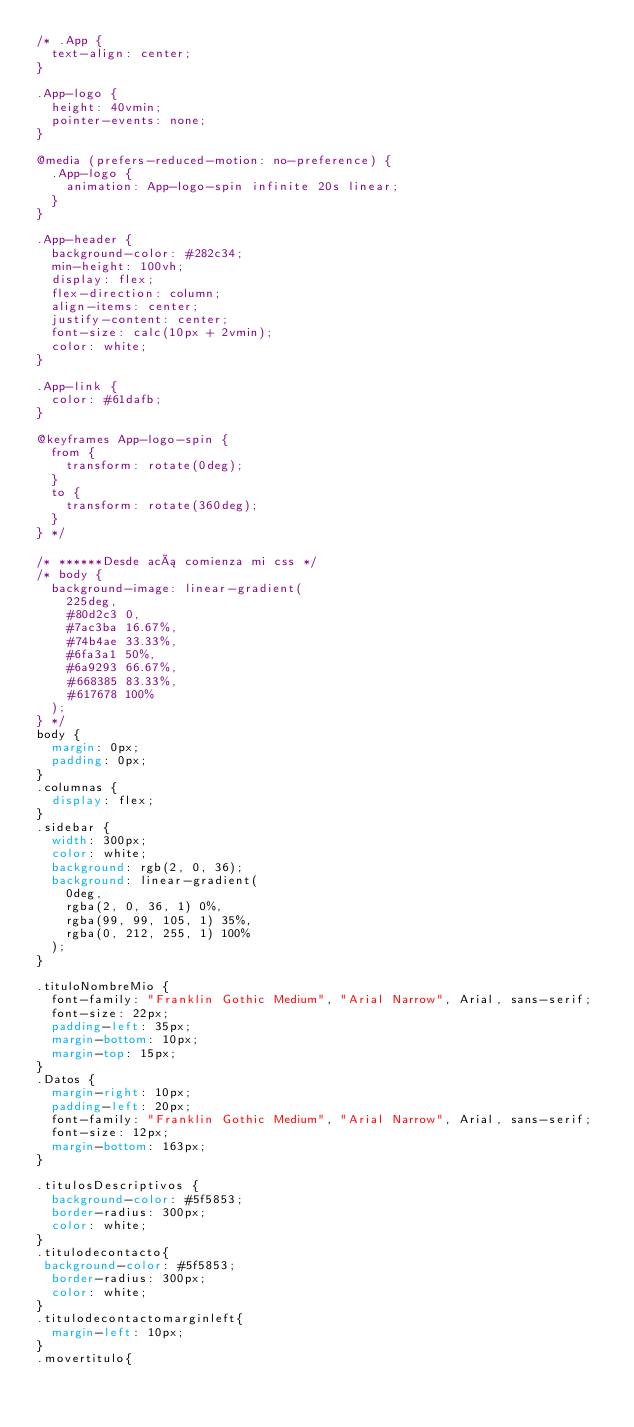<code> <loc_0><loc_0><loc_500><loc_500><_CSS_>/* .App {
  text-align: center;
}

.App-logo {
  height: 40vmin;
  pointer-events: none;
}

@media (prefers-reduced-motion: no-preference) {
  .App-logo {
    animation: App-logo-spin infinite 20s linear;
  }
}

.App-header {
  background-color: #282c34;
  min-height: 100vh;
  display: flex;
  flex-direction: column;
  align-items: center;
  justify-content: center;
  font-size: calc(10px + 2vmin);
  color: white;
}

.App-link {
  color: #61dafb;
}

@keyframes App-logo-spin {
  from {
    transform: rotate(0deg);
  }
  to {
    transform: rotate(360deg);
  }
} */

/* ******Desde acá comienza mi css */
/* body {
  background-image: linear-gradient(
    225deg,
    #80d2c3 0,
    #7ac3ba 16.67%,
    #74b4ae 33.33%,
    #6fa3a1 50%,
    #6a9293 66.67%,
    #668385 83.33%,
    #617678 100%
  );
} */
body {
  margin: 0px;
  padding: 0px;
}
.columnas {
  display: flex;
}
.sidebar {
  width: 300px;
  color: white;
  background: rgb(2, 0, 36);
  background: linear-gradient(
    0deg,
    rgba(2, 0, 36, 1) 0%,
    rgba(99, 99, 105, 1) 35%,
    rgba(0, 212, 255, 1) 100%
  );
}

.tituloNombreMio {
  font-family: "Franklin Gothic Medium", "Arial Narrow", Arial, sans-serif;
  font-size: 22px;
  padding-left: 35px;
  margin-bottom: 10px;
  margin-top: 15px;
}
.Datos {
  margin-right: 10px;
  padding-left: 20px;
  font-family: "Franklin Gothic Medium", "Arial Narrow", Arial, sans-serif;
  font-size: 12px;
  margin-bottom: 163px;
}

.titulosDescriptivos {
  background-color: #5f5853;
  border-radius: 300px;
  color: white;
}
.titulodecontacto{
 background-color: #5f5853;
  border-radius: 300px;
  color: white;
}
.titulodecontactomarginleft{
  margin-left: 10px;
}
.movertitulo{</code> 